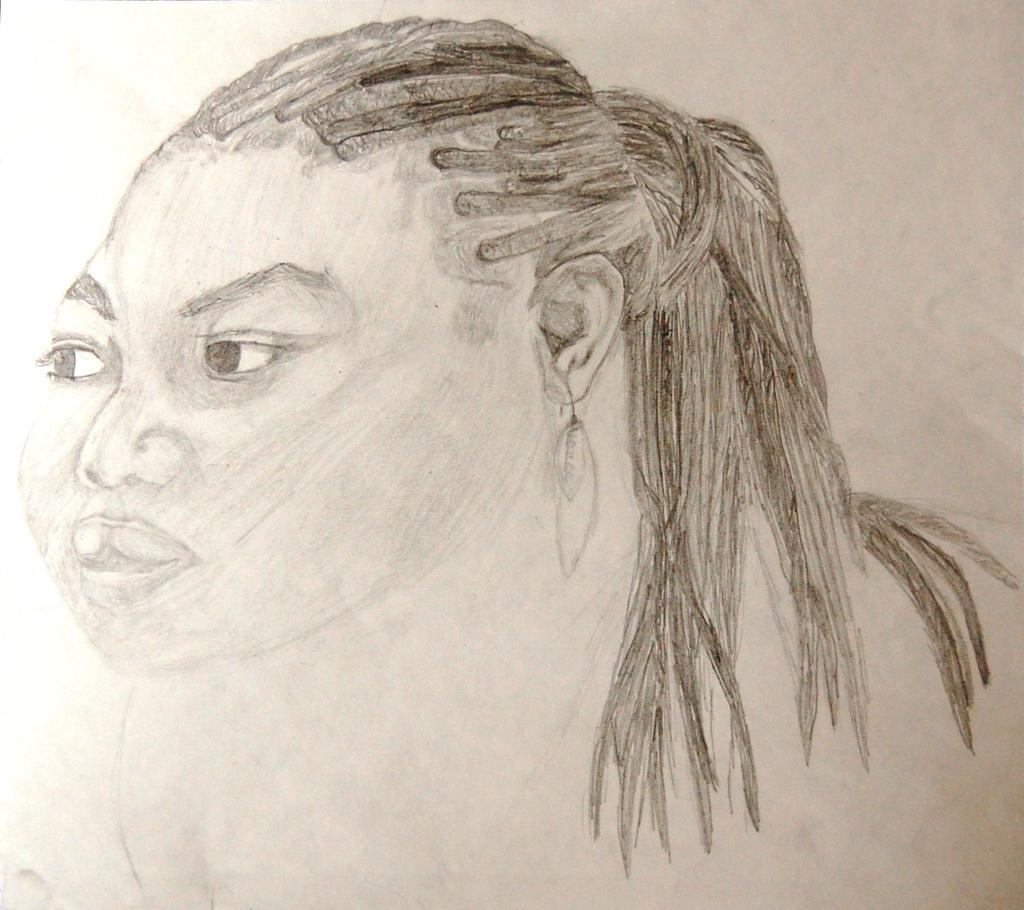What is the main subject of the image? The main subject of the image is a sketch of a girl. What accessory is the girl wearing in the sketch? The girl is wearing earrings in the sketch. What color is the background of the sketch? The background of the sketch is white in color. What is the girl doing to reduce pollution in the image? There is no indication of the girl taking any action to reduce pollution in the image, as it is a sketch of a girl wearing earrings with a white background. 